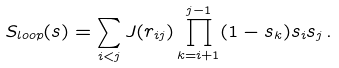Convert formula to latex. <formula><loc_0><loc_0><loc_500><loc_500>S _ { l o o p } ( { s } ) = \sum _ { i < j } J ( r _ { i j } ) \prod _ { k = i + 1 } ^ { j - 1 } ( 1 - s _ { k } ) s _ { i } s _ { j } \, .</formula> 